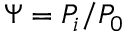<formula> <loc_0><loc_0><loc_500><loc_500>\Psi = P _ { i } / P _ { 0 }</formula> 